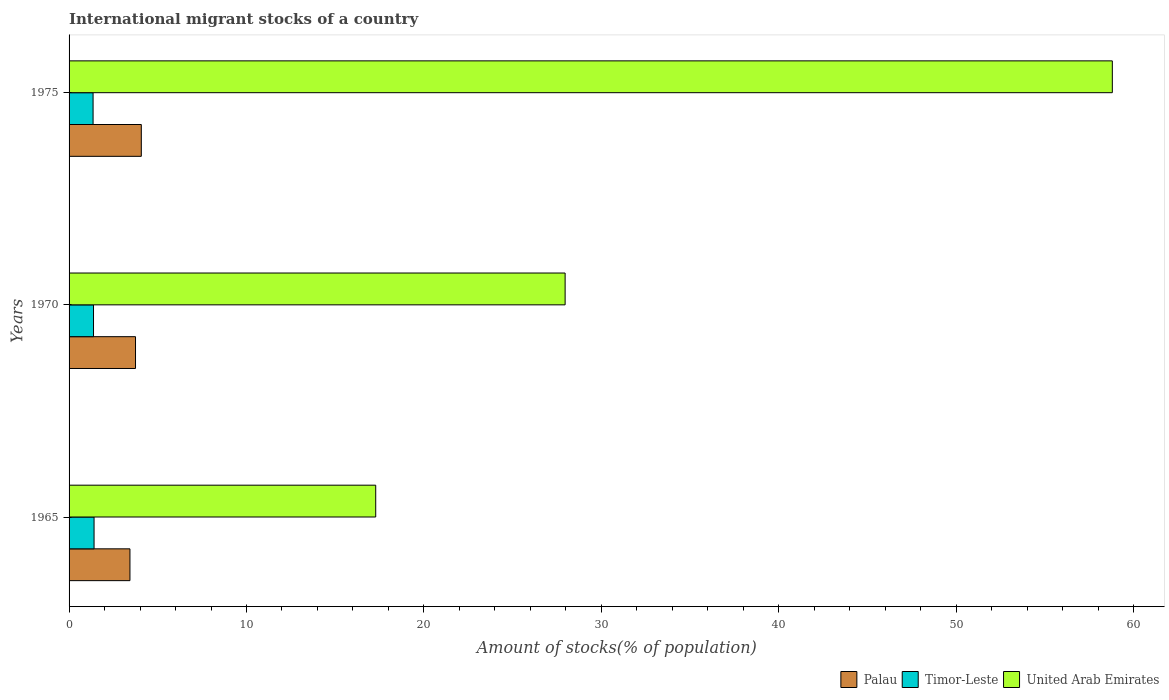Are the number of bars on each tick of the Y-axis equal?
Offer a very short reply. Yes. How many bars are there on the 2nd tick from the bottom?
Ensure brevity in your answer.  3. In how many cases, is the number of bars for a given year not equal to the number of legend labels?
Keep it short and to the point. 0. What is the amount of stocks in in Timor-Leste in 1965?
Your answer should be very brief. 1.41. Across all years, what is the maximum amount of stocks in in United Arab Emirates?
Give a very brief answer. 58.8. Across all years, what is the minimum amount of stocks in in Timor-Leste?
Keep it short and to the point. 1.35. In which year was the amount of stocks in in United Arab Emirates maximum?
Your answer should be very brief. 1975. In which year was the amount of stocks in in Palau minimum?
Give a very brief answer. 1965. What is the total amount of stocks in in United Arab Emirates in the graph?
Your response must be concise. 104.05. What is the difference between the amount of stocks in in Timor-Leste in 1965 and that in 1975?
Make the answer very short. 0.06. What is the difference between the amount of stocks in in United Arab Emirates in 1965 and the amount of stocks in in Palau in 1975?
Make the answer very short. 13.21. What is the average amount of stocks in in Palau per year?
Your answer should be very brief. 3.75. In the year 1975, what is the difference between the amount of stocks in in United Arab Emirates and amount of stocks in in Timor-Leste?
Your answer should be very brief. 57.45. In how many years, is the amount of stocks in in Palau greater than 2 %?
Ensure brevity in your answer.  3. What is the ratio of the amount of stocks in in Palau in 1970 to that in 1975?
Make the answer very short. 0.92. Is the difference between the amount of stocks in in United Arab Emirates in 1965 and 1970 greater than the difference between the amount of stocks in in Timor-Leste in 1965 and 1970?
Offer a terse response. No. What is the difference between the highest and the second highest amount of stocks in in United Arab Emirates?
Give a very brief answer. 30.84. What is the difference between the highest and the lowest amount of stocks in in United Arab Emirates?
Make the answer very short. 41.52. Is the sum of the amount of stocks in in United Arab Emirates in 1970 and 1975 greater than the maximum amount of stocks in in Palau across all years?
Ensure brevity in your answer.  Yes. What does the 1st bar from the top in 1970 represents?
Ensure brevity in your answer.  United Arab Emirates. What does the 3rd bar from the bottom in 1970 represents?
Make the answer very short. United Arab Emirates. Is it the case that in every year, the sum of the amount of stocks in in United Arab Emirates and amount of stocks in in Palau is greater than the amount of stocks in in Timor-Leste?
Offer a very short reply. Yes. What is the difference between two consecutive major ticks on the X-axis?
Give a very brief answer. 10. Does the graph contain grids?
Offer a terse response. No. How are the legend labels stacked?
Give a very brief answer. Horizontal. What is the title of the graph?
Give a very brief answer. International migrant stocks of a country. Does "Micronesia" appear as one of the legend labels in the graph?
Your answer should be very brief. No. What is the label or title of the X-axis?
Your answer should be very brief. Amount of stocks(% of population). What is the label or title of the Y-axis?
Your answer should be very brief. Years. What is the Amount of stocks(% of population) of Palau in 1965?
Provide a succinct answer. 3.43. What is the Amount of stocks(% of population) in Timor-Leste in 1965?
Ensure brevity in your answer.  1.41. What is the Amount of stocks(% of population) in United Arab Emirates in 1965?
Keep it short and to the point. 17.28. What is the Amount of stocks(% of population) of Palau in 1970?
Provide a succinct answer. 3.75. What is the Amount of stocks(% of population) in Timor-Leste in 1970?
Your answer should be very brief. 1.38. What is the Amount of stocks(% of population) in United Arab Emirates in 1970?
Give a very brief answer. 27.96. What is the Amount of stocks(% of population) of Palau in 1975?
Your answer should be very brief. 4.07. What is the Amount of stocks(% of population) in Timor-Leste in 1975?
Provide a succinct answer. 1.35. What is the Amount of stocks(% of population) in United Arab Emirates in 1975?
Your response must be concise. 58.8. Across all years, what is the maximum Amount of stocks(% of population) in Palau?
Ensure brevity in your answer.  4.07. Across all years, what is the maximum Amount of stocks(% of population) in Timor-Leste?
Keep it short and to the point. 1.41. Across all years, what is the maximum Amount of stocks(% of population) in United Arab Emirates?
Give a very brief answer. 58.8. Across all years, what is the minimum Amount of stocks(% of population) of Palau?
Provide a short and direct response. 3.43. Across all years, what is the minimum Amount of stocks(% of population) of Timor-Leste?
Give a very brief answer. 1.35. Across all years, what is the minimum Amount of stocks(% of population) of United Arab Emirates?
Provide a short and direct response. 17.28. What is the total Amount of stocks(% of population) in Palau in the graph?
Offer a very short reply. 11.25. What is the total Amount of stocks(% of population) in Timor-Leste in the graph?
Offer a very short reply. 4.14. What is the total Amount of stocks(% of population) in United Arab Emirates in the graph?
Your response must be concise. 104.05. What is the difference between the Amount of stocks(% of population) of Palau in 1965 and that in 1970?
Offer a terse response. -0.31. What is the difference between the Amount of stocks(% of population) of Timor-Leste in 1965 and that in 1970?
Offer a terse response. 0.03. What is the difference between the Amount of stocks(% of population) of United Arab Emirates in 1965 and that in 1970?
Provide a succinct answer. -10.68. What is the difference between the Amount of stocks(% of population) in Palau in 1965 and that in 1975?
Make the answer very short. -0.64. What is the difference between the Amount of stocks(% of population) of Timor-Leste in 1965 and that in 1975?
Keep it short and to the point. 0.06. What is the difference between the Amount of stocks(% of population) of United Arab Emirates in 1965 and that in 1975?
Keep it short and to the point. -41.52. What is the difference between the Amount of stocks(% of population) in Palau in 1970 and that in 1975?
Provide a short and direct response. -0.33. What is the difference between the Amount of stocks(% of population) of Timor-Leste in 1970 and that in 1975?
Give a very brief answer. 0.02. What is the difference between the Amount of stocks(% of population) of United Arab Emirates in 1970 and that in 1975?
Your answer should be very brief. -30.84. What is the difference between the Amount of stocks(% of population) in Palau in 1965 and the Amount of stocks(% of population) in Timor-Leste in 1970?
Offer a very short reply. 2.05. What is the difference between the Amount of stocks(% of population) of Palau in 1965 and the Amount of stocks(% of population) of United Arab Emirates in 1970?
Your answer should be compact. -24.53. What is the difference between the Amount of stocks(% of population) in Timor-Leste in 1965 and the Amount of stocks(% of population) in United Arab Emirates in 1970?
Make the answer very short. -26.55. What is the difference between the Amount of stocks(% of population) of Palau in 1965 and the Amount of stocks(% of population) of Timor-Leste in 1975?
Your answer should be compact. 2.08. What is the difference between the Amount of stocks(% of population) in Palau in 1965 and the Amount of stocks(% of population) in United Arab Emirates in 1975?
Your answer should be compact. -55.37. What is the difference between the Amount of stocks(% of population) of Timor-Leste in 1965 and the Amount of stocks(% of population) of United Arab Emirates in 1975?
Provide a succinct answer. -57.39. What is the difference between the Amount of stocks(% of population) of Palau in 1970 and the Amount of stocks(% of population) of Timor-Leste in 1975?
Your answer should be very brief. 2.39. What is the difference between the Amount of stocks(% of population) in Palau in 1970 and the Amount of stocks(% of population) in United Arab Emirates in 1975?
Give a very brief answer. -55.06. What is the difference between the Amount of stocks(% of population) of Timor-Leste in 1970 and the Amount of stocks(% of population) of United Arab Emirates in 1975?
Provide a succinct answer. -57.42. What is the average Amount of stocks(% of population) of Palau per year?
Offer a terse response. 3.75. What is the average Amount of stocks(% of population) of Timor-Leste per year?
Keep it short and to the point. 1.38. What is the average Amount of stocks(% of population) in United Arab Emirates per year?
Provide a succinct answer. 34.68. In the year 1965, what is the difference between the Amount of stocks(% of population) in Palau and Amount of stocks(% of population) in Timor-Leste?
Your answer should be very brief. 2.02. In the year 1965, what is the difference between the Amount of stocks(% of population) in Palau and Amount of stocks(% of population) in United Arab Emirates?
Keep it short and to the point. -13.85. In the year 1965, what is the difference between the Amount of stocks(% of population) of Timor-Leste and Amount of stocks(% of population) of United Arab Emirates?
Your response must be concise. -15.88. In the year 1970, what is the difference between the Amount of stocks(% of population) of Palau and Amount of stocks(% of population) of Timor-Leste?
Provide a succinct answer. 2.37. In the year 1970, what is the difference between the Amount of stocks(% of population) of Palau and Amount of stocks(% of population) of United Arab Emirates?
Offer a terse response. -24.21. In the year 1970, what is the difference between the Amount of stocks(% of population) of Timor-Leste and Amount of stocks(% of population) of United Arab Emirates?
Your answer should be compact. -26.58. In the year 1975, what is the difference between the Amount of stocks(% of population) in Palau and Amount of stocks(% of population) in Timor-Leste?
Your response must be concise. 2.72. In the year 1975, what is the difference between the Amount of stocks(% of population) of Palau and Amount of stocks(% of population) of United Arab Emirates?
Provide a short and direct response. -54.73. In the year 1975, what is the difference between the Amount of stocks(% of population) of Timor-Leste and Amount of stocks(% of population) of United Arab Emirates?
Your answer should be very brief. -57.45. What is the ratio of the Amount of stocks(% of population) in Palau in 1965 to that in 1970?
Give a very brief answer. 0.92. What is the ratio of the Amount of stocks(% of population) of Timor-Leste in 1965 to that in 1970?
Provide a succinct answer. 1.02. What is the ratio of the Amount of stocks(% of population) of United Arab Emirates in 1965 to that in 1970?
Make the answer very short. 0.62. What is the ratio of the Amount of stocks(% of population) of Palau in 1965 to that in 1975?
Your answer should be very brief. 0.84. What is the ratio of the Amount of stocks(% of population) of Timor-Leste in 1965 to that in 1975?
Make the answer very short. 1.04. What is the ratio of the Amount of stocks(% of population) of United Arab Emirates in 1965 to that in 1975?
Make the answer very short. 0.29. What is the ratio of the Amount of stocks(% of population) of Palau in 1970 to that in 1975?
Provide a short and direct response. 0.92. What is the ratio of the Amount of stocks(% of population) in Timor-Leste in 1970 to that in 1975?
Provide a succinct answer. 1.02. What is the ratio of the Amount of stocks(% of population) in United Arab Emirates in 1970 to that in 1975?
Provide a short and direct response. 0.48. What is the difference between the highest and the second highest Amount of stocks(% of population) in Palau?
Offer a terse response. 0.33. What is the difference between the highest and the second highest Amount of stocks(% of population) in Timor-Leste?
Make the answer very short. 0.03. What is the difference between the highest and the second highest Amount of stocks(% of population) of United Arab Emirates?
Offer a very short reply. 30.84. What is the difference between the highest and the lowest Amount of stocks(% of population) of Palau?
Offer a terse response. 0.64. What is the difference between the highest and the lowest Amount of stocks(% of population) in Timor-Leste?
Provide a succinct answer. 0.06. What is the difference between the highest and the lowest Amount of stocks(% of population) of United Arab Emirates?
Keep it short and to the point. 41.52. 